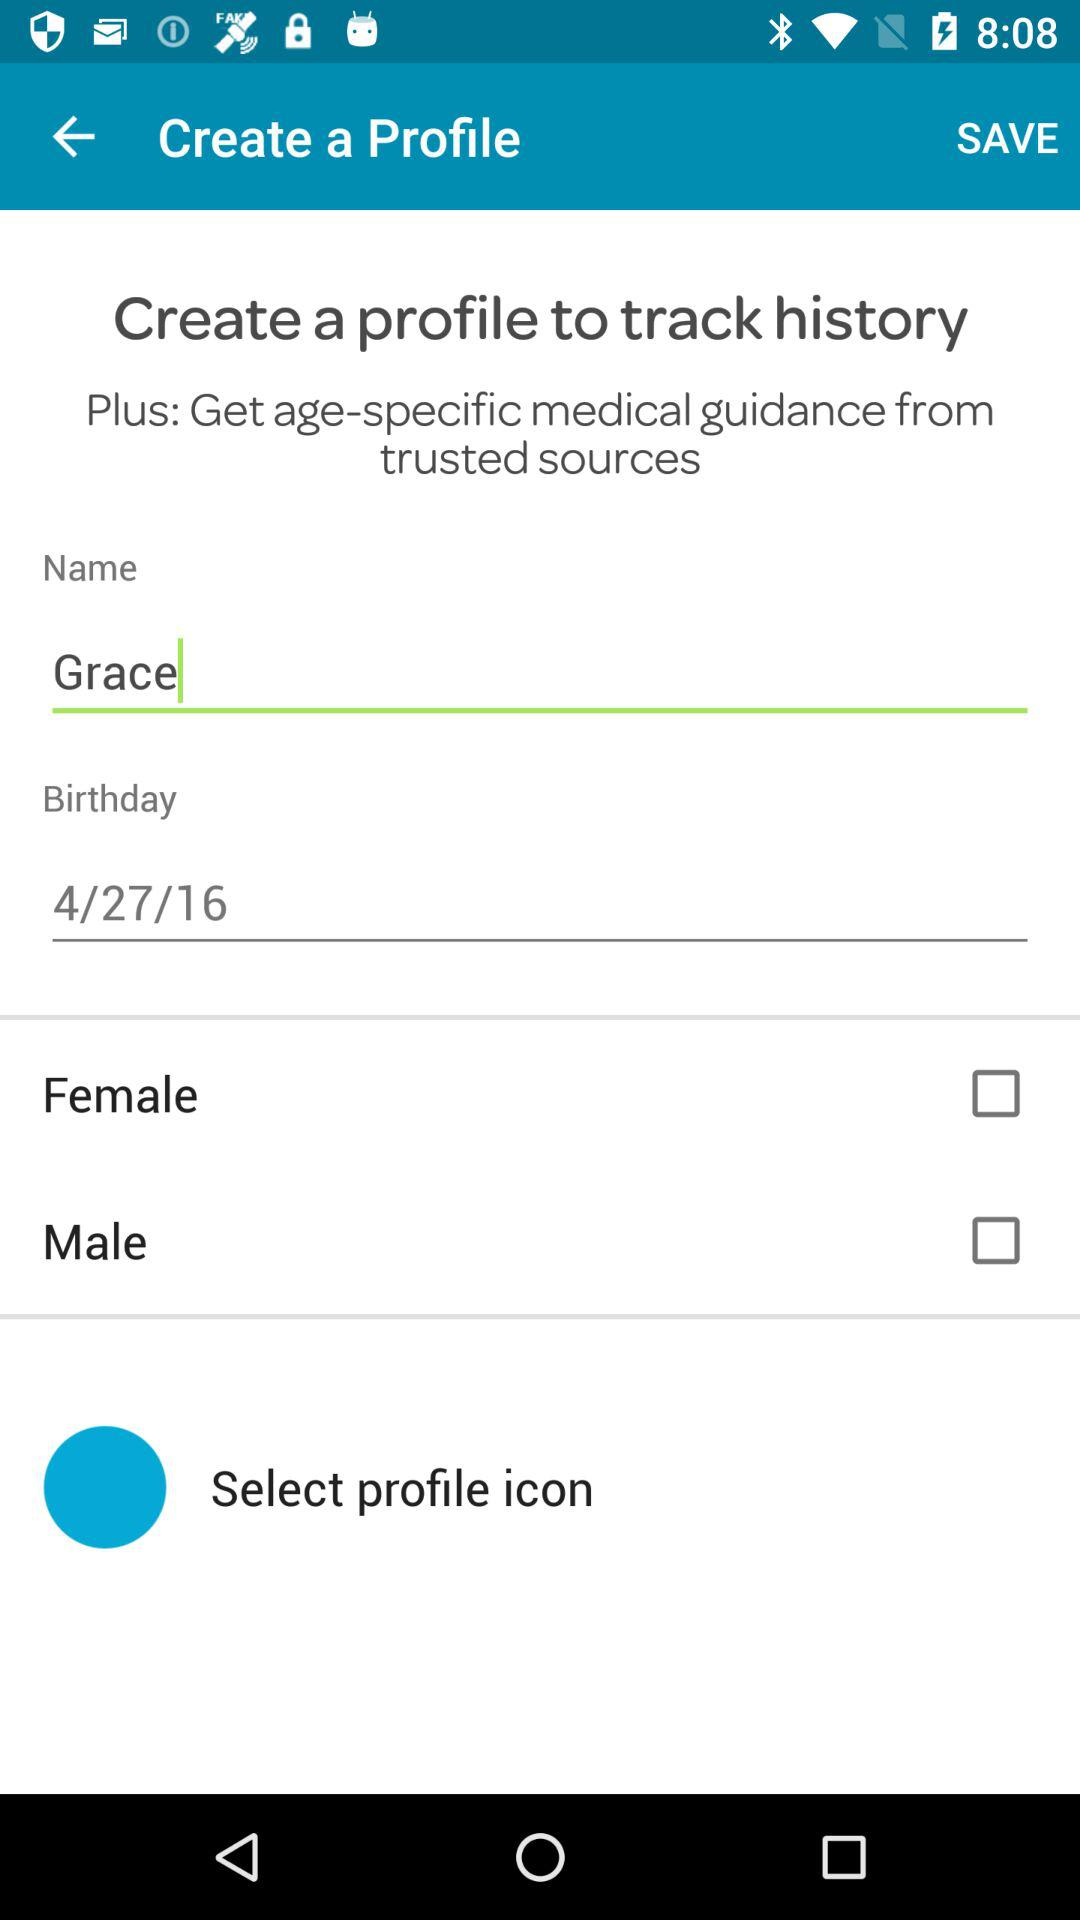What's the birth date? The birth date is April 27, 2016. 